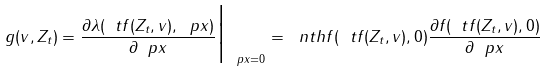<formula> <loc_0><loc_0><loc_500><loc_500>g ( v , Z _ { t } ) = \frac { \partial \lambda ( \ t f ( Z _ { t } , v ) , \ p x ) } { \partial \ p x } \Big | _ { \ p x = 0 } = \ n t h { f ( \ t f ( Z _ { t } , v ) , 0 ) } \frac { \partial f ( \ t f ( Z _ { t } , v ) , 0 ) } { \partial \ p x }</formula> 